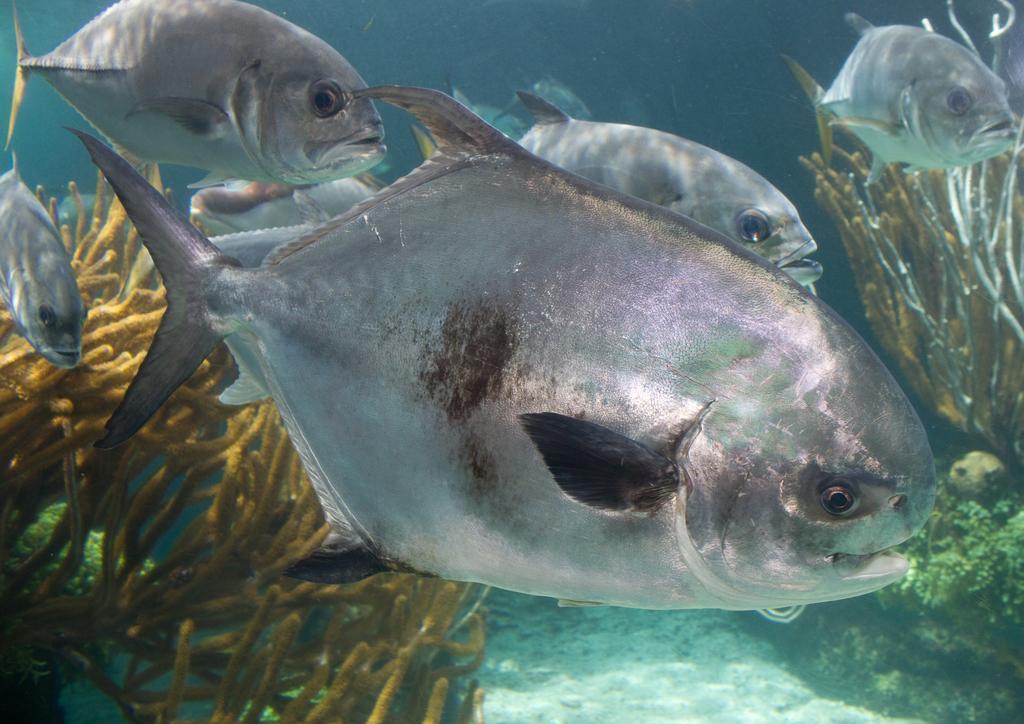How would you summarize this image in a sentence or two? In this image there are fishes in the water. At the bottom there are sea plants. 